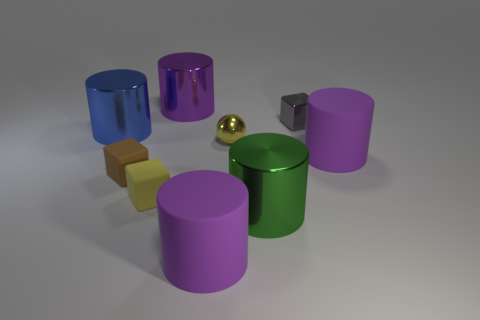How many things are either objects behind the tiny metallic cube or gray cubes?
Your answer should be very brief. 2. How many things are either tiny brown cubes or things behind the big blue object?
Make the answer very short. 3. How many other metallic things have the same size as the purple metallic object?
Your response must be concise. 2. Is the number of big purple cylinders that are behind the purple shiny cylinder less than the number of purple rubber cylinders that are in front of the green shiny thing?
Ensure brevity in your answer.  Yes. What number of matte things are either big purple things or gray cubes?
Offer a terse response. 2. What is the shape of the yellow rubber thing?
Your answer should be very brief. Cube. What is the material of the blue thing that is the same size as the green metal cylinder?
Your answer should be very brief. Metal. What number of tiny things are cubes or purple shiny objects?
Your answer should be compact. 3. Are there any rubber cubes?
Your answer should be very brief. Yes. The purple thing that is the same material as the green cylinder is what size?
Your answer should be compact. Large. 